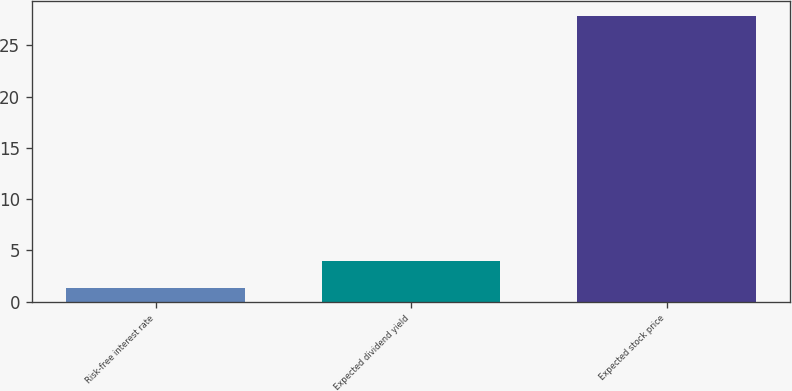<chart> <loc_0><loc_0><loc_500><loc_500><bar_chart><fcel>Risk-free interest rate<fcel>Expected dividend yield<fcel>Expected stock price<nl><fcel>1.3<fcel>3.96<fcel>27.9<nl></chart> 